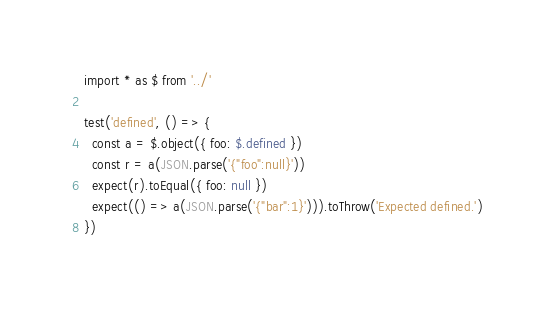Convert code to text. <code><loc_0><loc_0><loc_500><loc_500><_TypeScript_>import * as $ from '../'

test('defined', () => {
  const a = $.object({ foo: $.defined })
  const r = a(JSON.parse('{"foo":null}'))
  expect(r).toEqual({ foo: null })
  expect(() => a(JSON.parse('{"bar":1}'))).toThrow('Expected defined.')
})
</code> 